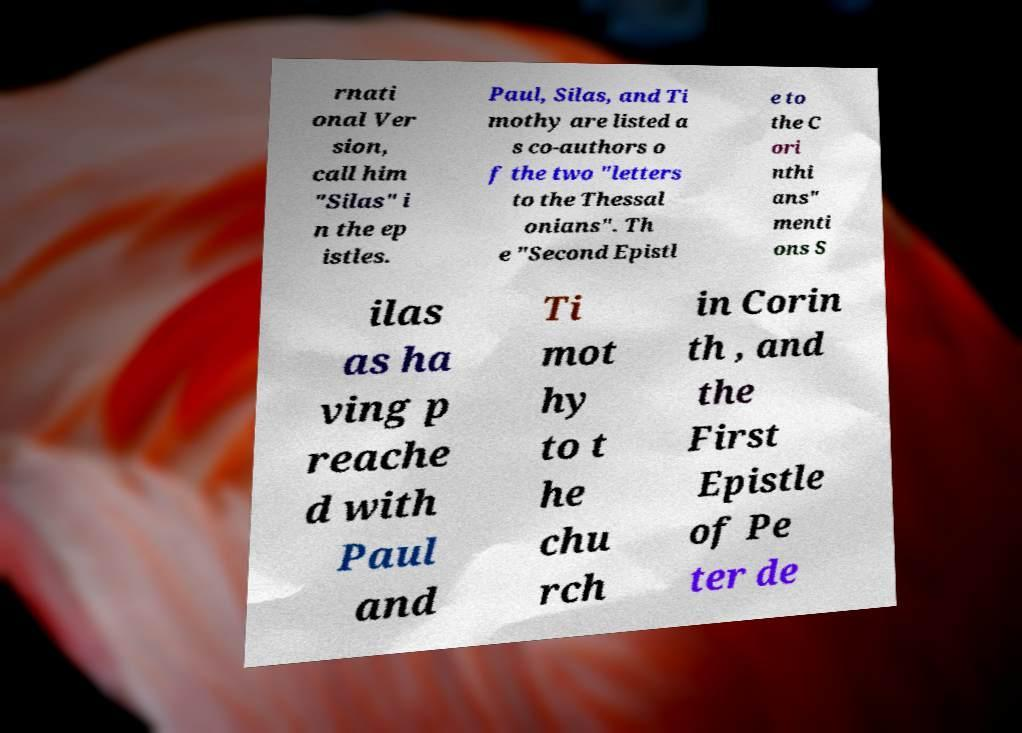Could you assist in decoding the text presented in this image and type it out clearly? rnati onal Ver sion, call him "Silas" i n the ep istles. Paul, Silas, and Ti mothy are listed a s co-authors o f the two "letters to the Thessal onians". Th e "Second Epistl e to the C ori nthi ans" menti ons S ilas as ha ving p reache d with Paul and Ti mot hy to t he chu rch in Corin th , and the First Epistle of Pe ter de 